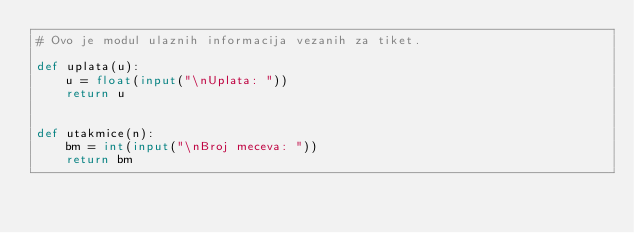<code> <loc_0><loc_0><loc_500><loc_500><_Python_># Ovo je modul ulaznih informacija vezanih za tiket.

def uplata(u):
    u = float(input("\nUplata: "))
    return u


def utakmice(n):
    bm = int(input("\nBroj meceva: "))
    return bm
</code> 